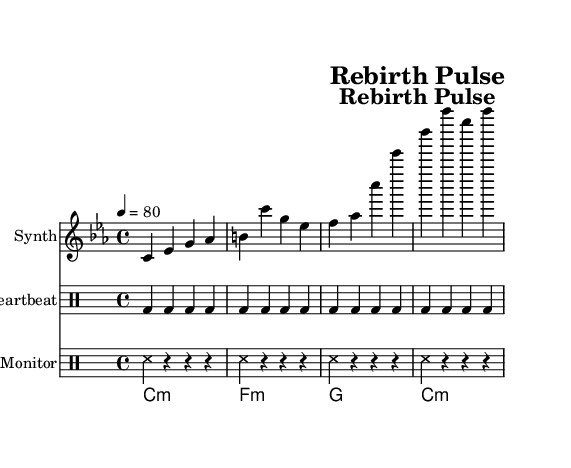What is the key signature of this music? The key signature is C minor, which has three flats: B flat, E flat, and A flat. This is indicated at the beginning of the music sheet.
Answer: C minor What is the time signature of this piece? The time signature is 4/4, which indicates there are four beats per measure, and the quarter note gets one beat. This is also shown at the beginning of the piece.
Answer: 4/4 What is the tempo marking? The tempo marking is 80 beats per minute, indicated as "4 = 80". This means the quarter note receives 80 beats per minute.
Answer: 80 How many measures does the synthesizer part have? The synthesizer part has four measures, as seen by counting the distinct sections between the vertical bars. Each section is separated by a bar line.
Answer: 4 What type of instrument is used for the medical monitor beep? The medical monitor beep is performed using a drum staff, indicated by the specific notation within the drum section labeled "Monitor".
Answer: DrumStaff What chord is used in the first measure of the ambient pad? The first measure of the ambient pad features a C minor chord, which is specified as "c1:m" in the chord notation.
Answer: C minor 